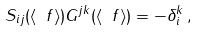Convert formula to latex. <formula><loc_0><loc_0><loc_500><loc_500>S _ { i j } ( \langle \ f \rangle ) G ^ { j k } ( \langle \ f \rangle ) = - \delta ^ { k } _ { i } \, ,</formula> 